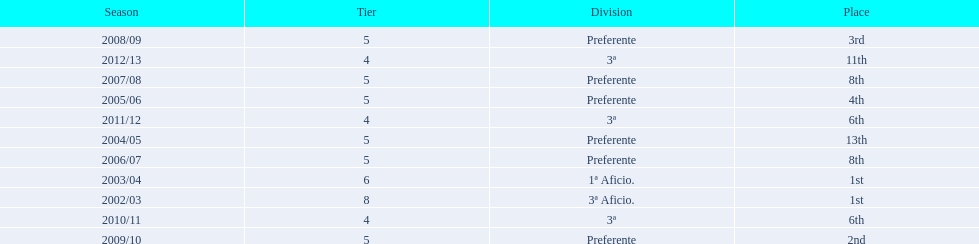How many times did  internacional de madrid cf come in 6th place? 6th, 6th. What is the first season that the team came in 6th place? 2010/11. Which season after the first did they place in 6th again? 2011/12. 